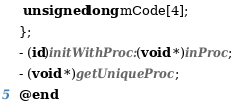Convert code to text. <code><loc_0><loc_0><loc_500><loc_500><_ObjectiveC_> unsigned long mCode[4];
};
- (id)initWithProc:(void *)inProc;
- (void *)getUniqueProc;
@end
</code> 